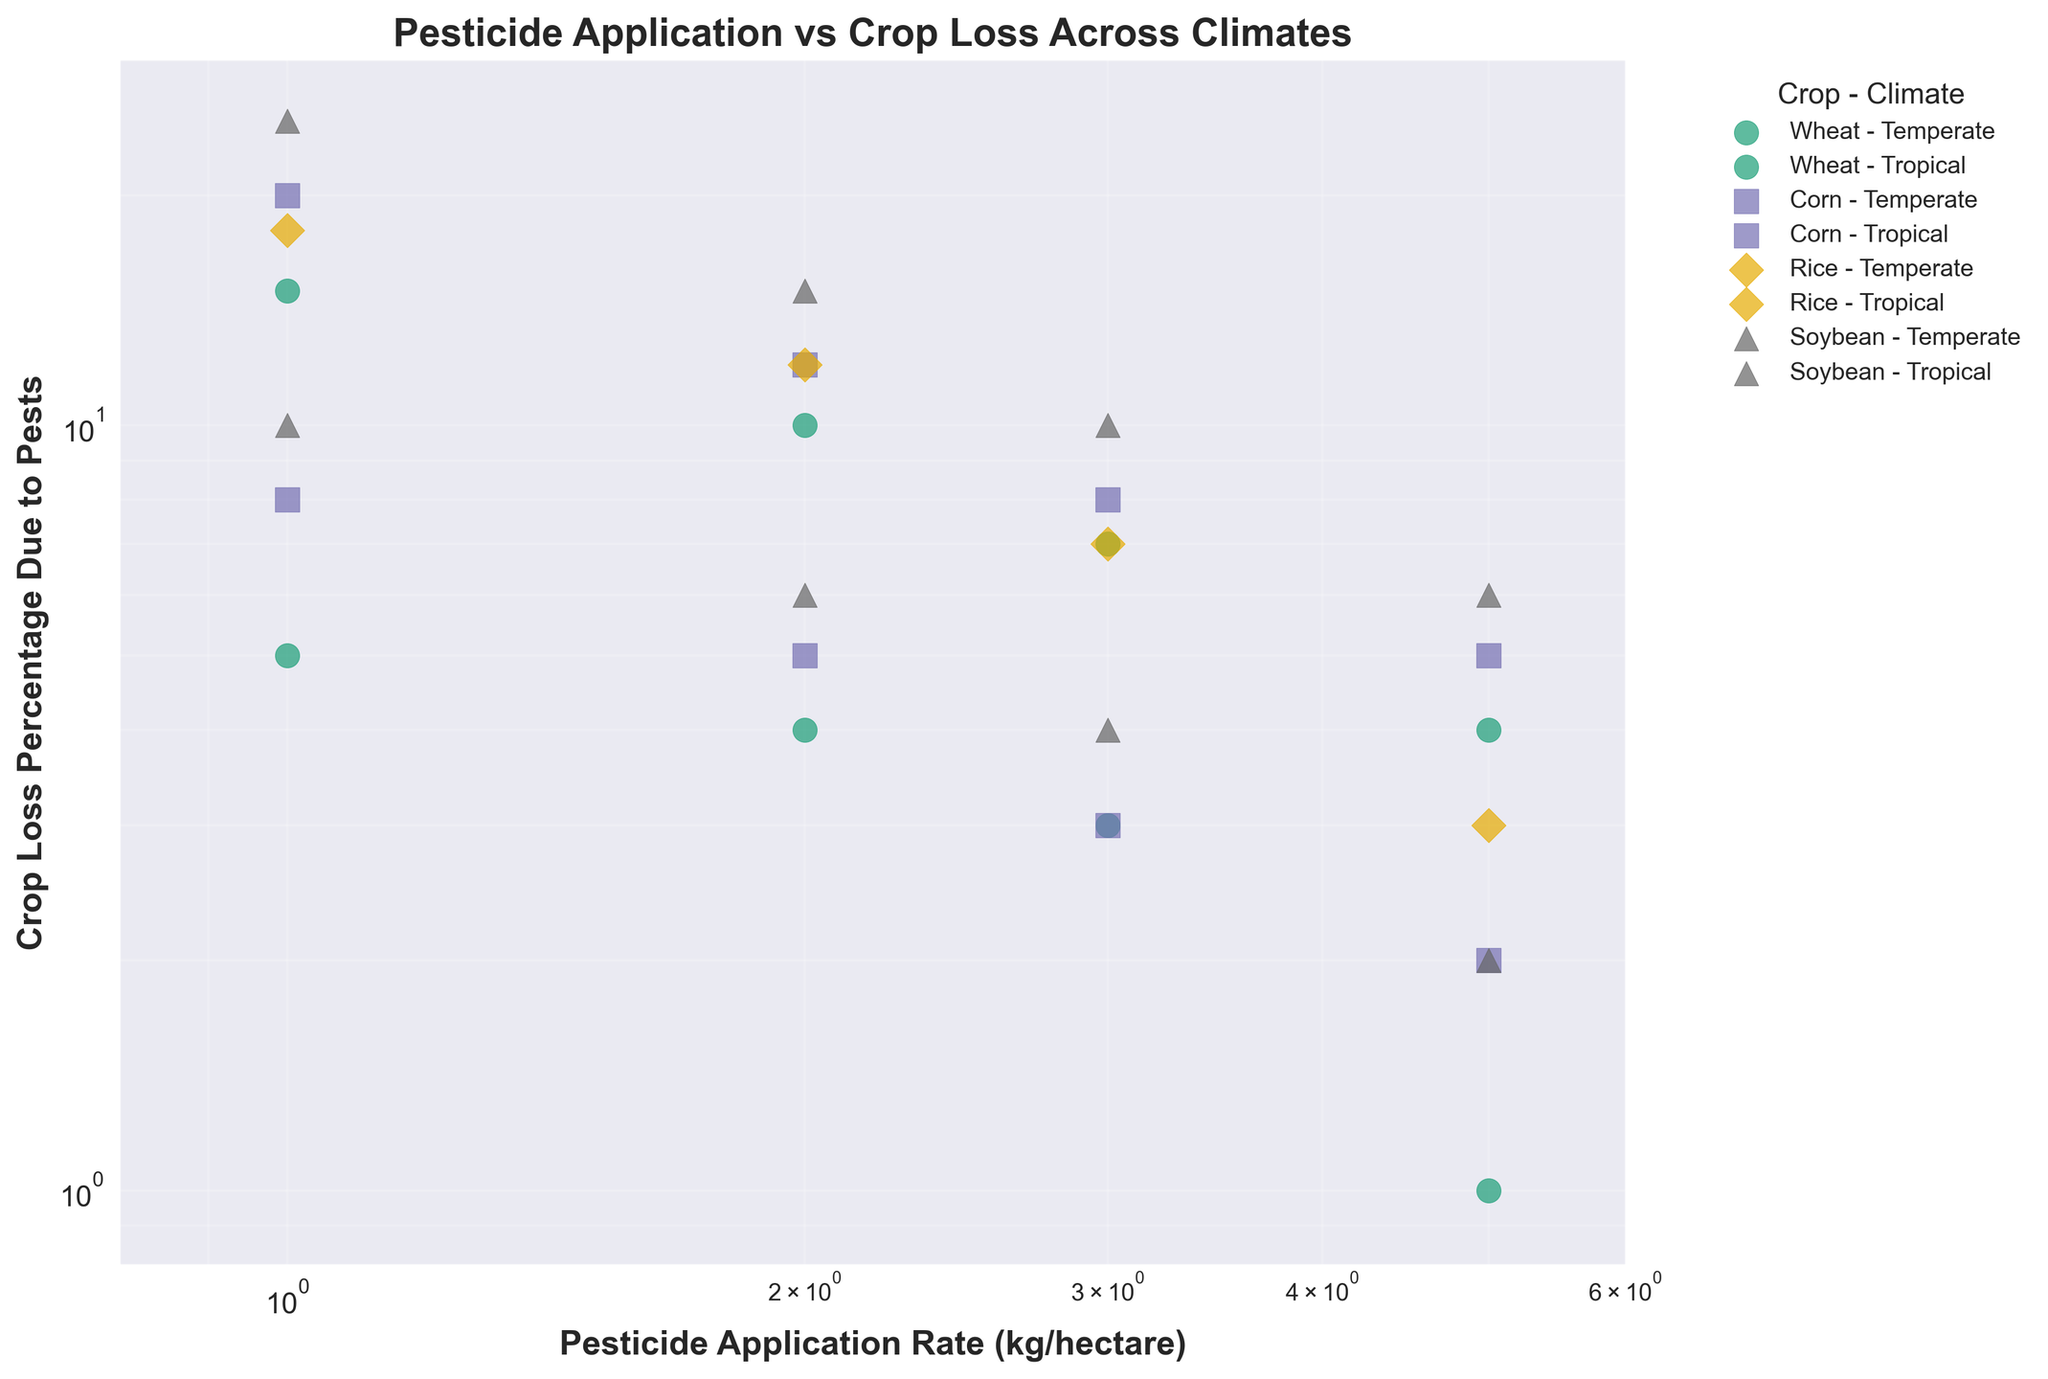What is the title of the figure? The title is typically located at the top of the plot. Reading it directly gives the answer.
Answer: Pesticide Application vs Crop Loss Across Climates What are the x and y axes representing, and how are they scaled? The x-axis label "Pesticide Application Rate (kg/hectare)" and the y-axis label "Crop Loss Percentage Due to Pests" indicate what they represent. Both axes use a log scale, as shown by the labeling.
Answer: Pesticide Application Rate (kg/hectare) and Crop Loss Percentage Due to Pests, both on a log scale How many different crops and climates are shown in the figure? The legend lists all combinations of crops and climates, and by counting these combinations, we can determine the number.
Answer: Four crops and two climates Which crop and climate combination has the highest crop loss percentage for a pesticide application rate of 1.0 kg/hectare? For a pesticide application rate of 1.0 kg/hectare, locate the corresponding points and compare the crop loss percentages.
Answer: Soybean - Tropical How does crop loss percentage change with increasing pesticide application rate for Temperate Corn? Identify the Temperate Corn data points and observe how the crop loss percentages trend as the pesticide application rate increases.
Answer: It decreases Between Wheat and Corn in Tropical climates, which one shows a steeper reduction in crop loss percentage as pesticide application rate increases? Compare the slope of the trend lines or data point distribution for Wheat and Corn in Tropical climates.
Answer: Corn At a pesticide application rate of 3.0 kg/hectare, which crop and climate combination has the lowest crop loss percentage? Look for the data points at 3.0 kg/hectare and compare crop loss percentages across all crop-climate combinations.
Answer: Wheat - Temperate What can be inferred about the relationship between pesticide application and crop loss in tropical climates? Observe the overall trend of data points for crops in tropical climates.
Answer: Crop loss decreases as pesticide application increases What observation can be made about the range of crop loss percentages at different pesticide application rates across all data points? Look at the distribution spread of crop loss percentages along different pesticide application rates on the plot.
Answer: Wider range at lower pesticide rates, narrower range at higher rates 